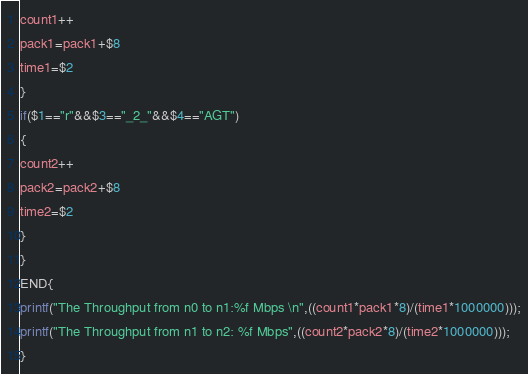<code> <loc_0><loc_0><loc_500><loc_500><_Awk_>count1++
pack1=pack1+$8
time1=$2
}
if($1=="r"&&$3=="_2_"&&$4=="AGT")
{
count2++
pack2=pack2+$8
time2=$2
}
}
END{
printf("The Throughput from n0 to n1:%f Mbps \n",((count1*pack1*8)/(time1*1000000)));
printf("The Throughput from n1 to n2: %f Mbps",((count2*pack2*8)/(time2*1000000)));
}</code> 